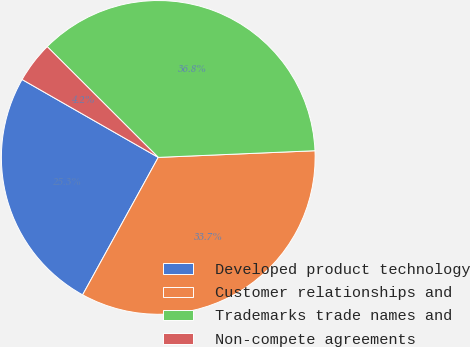Convert chart to OTSL. <chart><loc_0><loc_0><loc_500><loc_500><pie_chart><fcel>Developed product technology<fcel>Customer relationships and<fcel>Trademarks trade names and<fcel>Non-compete agreements<nl><fcel>25.26%<fcel>33.68%<fcel>36.84%<fcel>4.21%<nl></chart> 